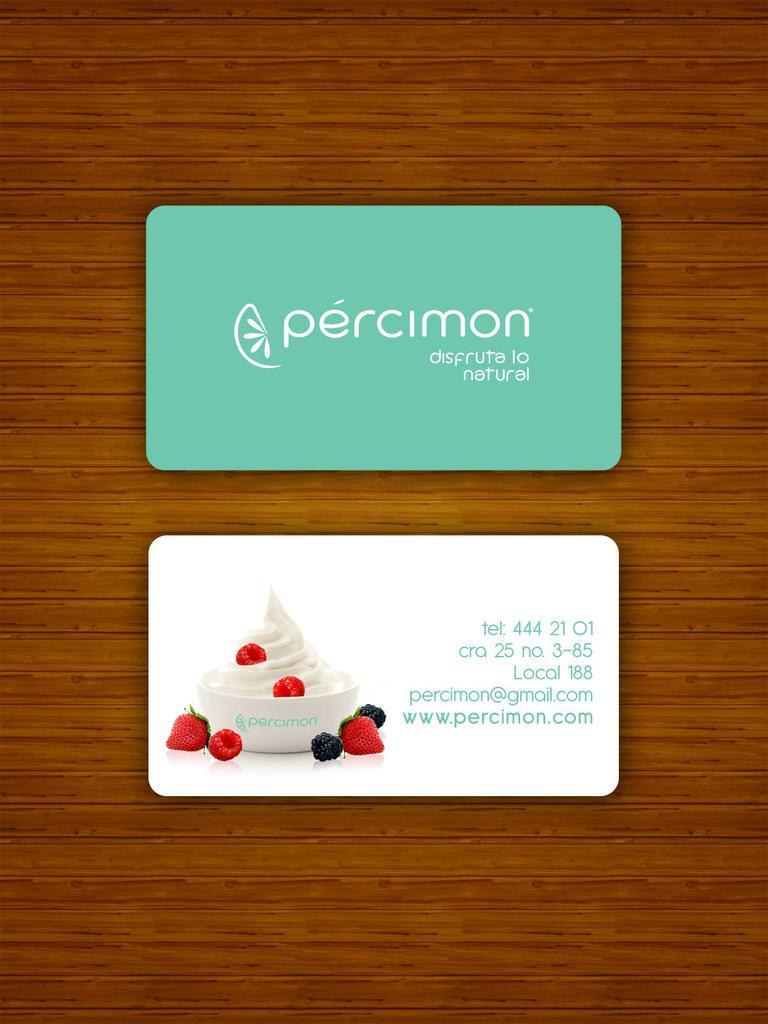Describe this image in one or two sentences. In this image we can see one card with text and logo. There is one white card with text, numbers, few fruits and one white bowl with food. It looks like a wall in the background. 